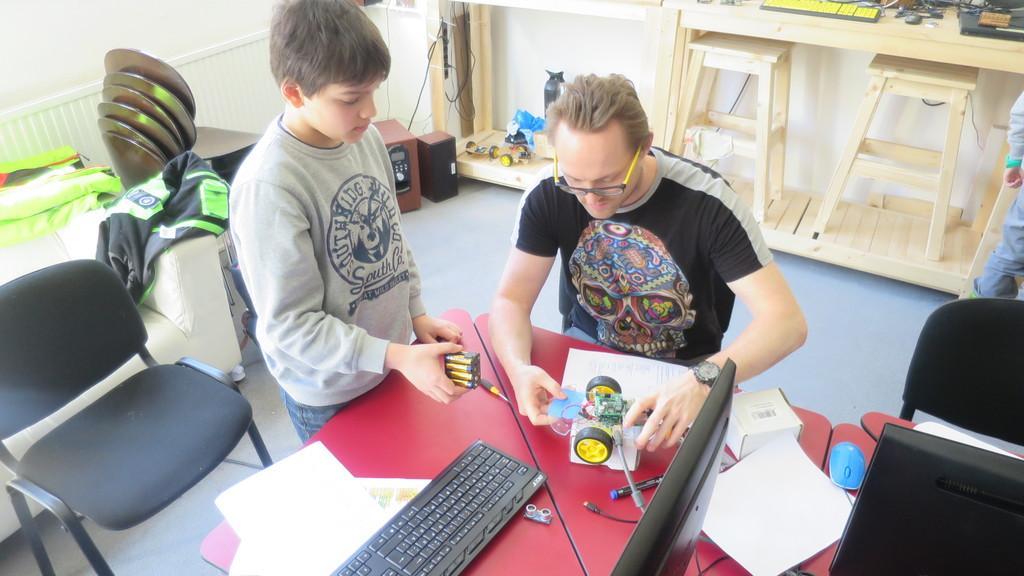Please provide a concise description of this image. In this image we can see a person and a boy. Person is wearing specs and watch. And he is holding something in the hand. And the boy is holding something in the hand. There are tables. On the tables there are papers, keyboard, box, pen and some other items. And there are chairs. In the back there are stools. And there are tables. On the tables there are many items. And there are many other items in the room. 